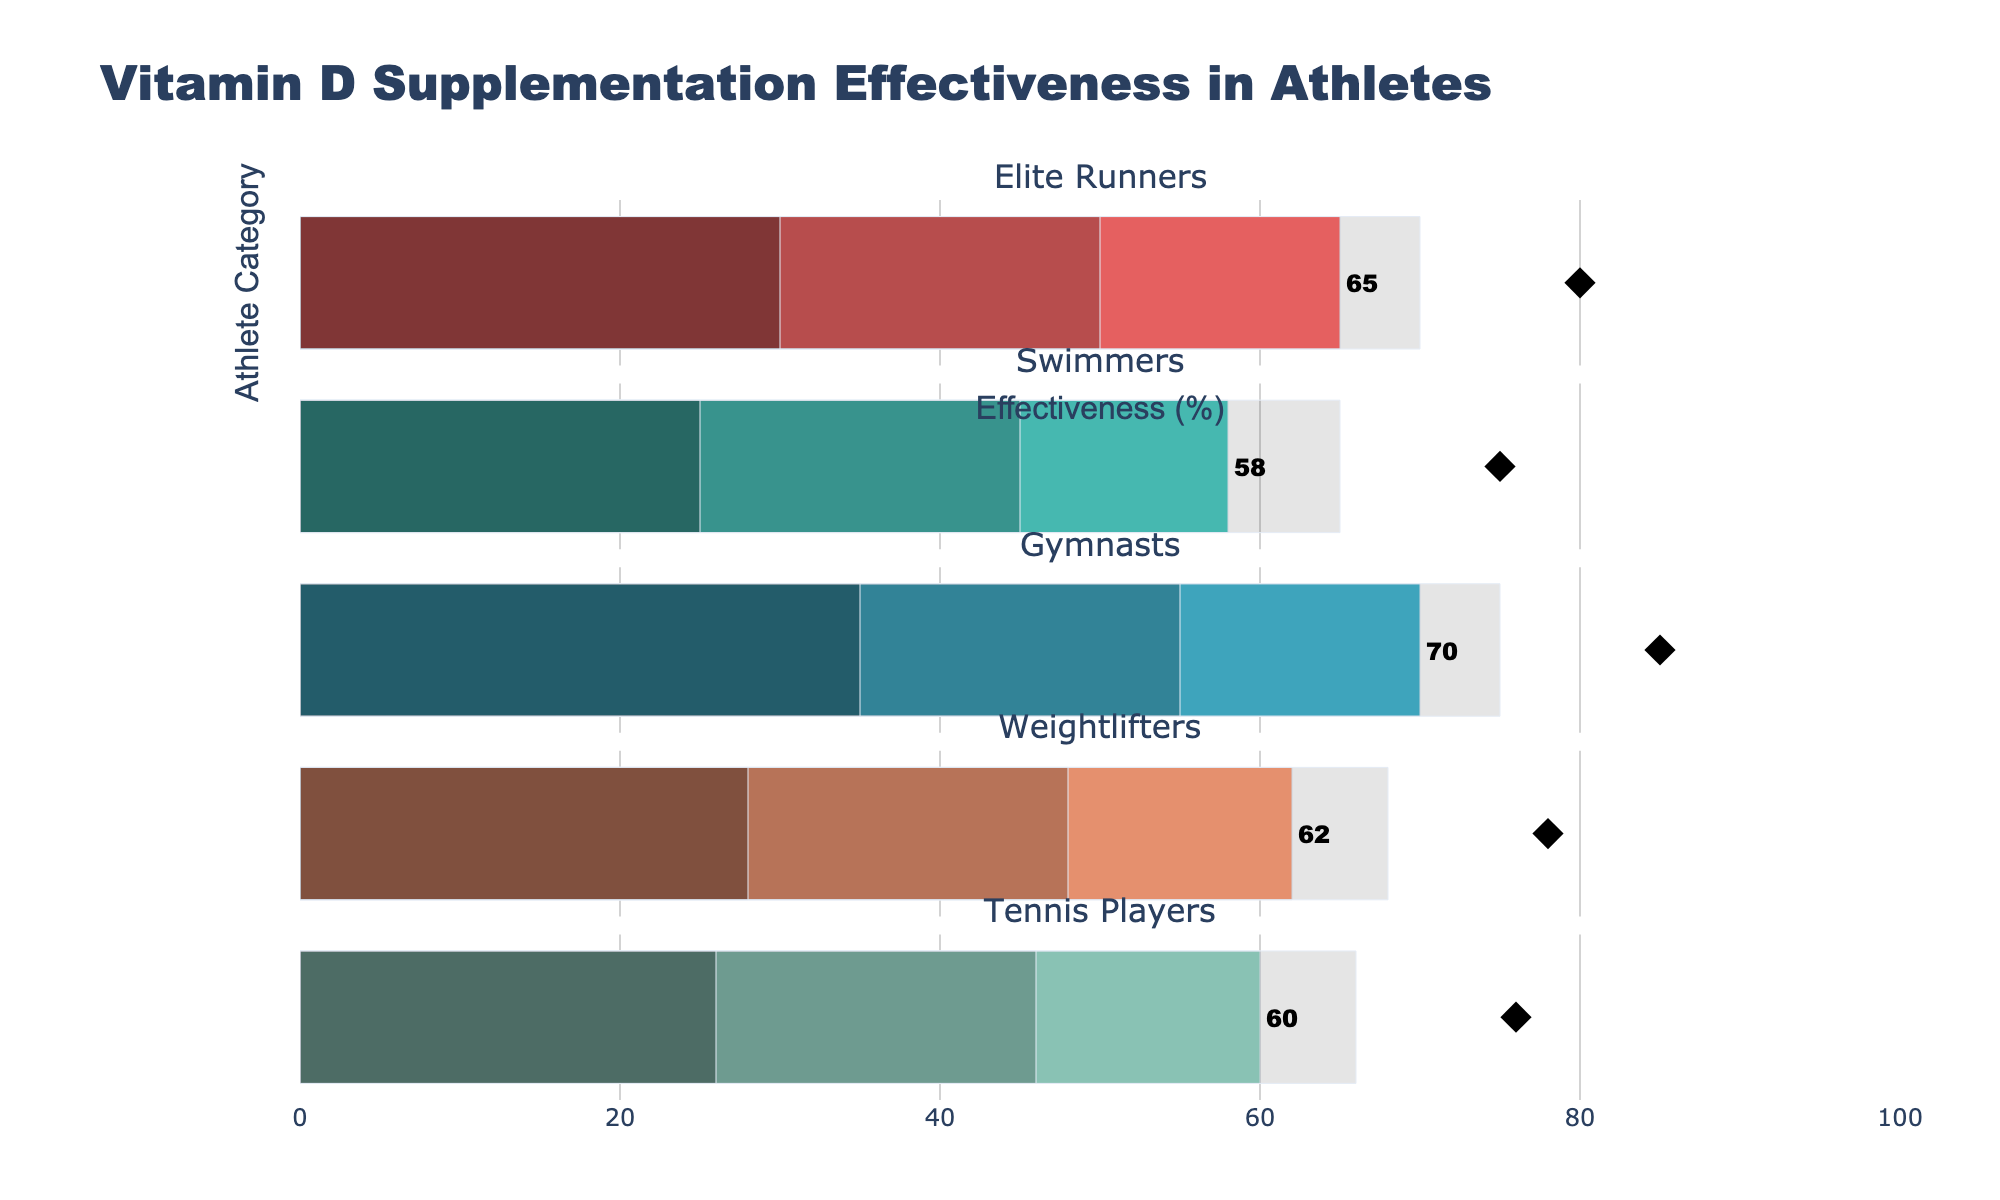What is the title of the figure? The title of the figure is located at the top and reads "Vitamin D Supplementation Effectiveness in Athletes".
Answer: Vitamin D Supplementation Effectiveness in Athletes What is the actual effectiveness percentage for Elite Runners? The actual effectiveness for each athlete category is represented by the bar with a specific color and the text label "Actual" beneath it. For Elite Runners, this bar indicates an effectiveness of 65%.
Answer: 65% Which athlete category has the highest target percentage for Vitamin D effectiveness? To determine which category has the highest target percentage, look for the diamond marker labeled "Target" and check its corresponding value. Gymnasts have a target percentage of 85%, the highest among all categories.
Answer: Gymnasts What is the difference between the actual and target effectiveness for Weightlifters? For Weightlifters, the actual effectiveness is 62%, and the target is 78%. The difference can be calculated as 78% - 62% = 16%.
Answer: 16% Which athlete categories have an actual effectiveness percentage greater than their respective Range2 value? By comparing each category's actual effectiveness percentage with their Range2 value: Elite Runners (65 > 50), Swimmers (58 > 45), Gymnasts (70 > 55), Weightlifters (62 > 48), and Tennis Players (60 > 46). All categories have actual effectiveness greater than their Range2.
Answer: All categories How many categories nearly meet or exceed their target effectiveness? (Within 10% range) To find how many categories are within 10% of meeting or exceeding their target, examine the difference between the actual and target values. Elite Runners (65 vs. 80, diff = 15%), Swimmers (58 vs. 75, diff = 17%), Gymnasts (70 vs. 85, diff = 15%), Weightlifters (62 vs. 78, diff = 16%), Tennis Players (60 vs. 76, diff = 16%). None of the categories meet this criterion.
Answer: 0 Identify the athlete category with the lowest actual effectiveness and provide its rate. By reviewing the "Actual" bars, Swimmers have the lowest effectiveness percentage at 58%.
Answer: Swimmers, 58% What is the average actual effectiveness percentage across all athlete categories? Add the actual effectiveness values and divide by the number of categories: (65 + 58 + 70 + 62 + 60) / 5 = 63.
Answer: 63% Which athlete category has the narrowest range of values between Range1 and Range3? Calculate the difference between Range1 and Range3 for each category: Elite Runners (70 - 30 = 40), Swimmers (65 - 25 = 40), Gymnasts (75 - 35 = 40), Weightlifters (68 - 28 = 40), Tennis Players (66 - 26 = 40). All categories have the same difference of 40.
Answer: All categories Is there a category where the actual effectiveness is below the Range1 value? Compare the actual effectiveness values to their corresponding Range1 values. None fall below their Range1 values.
Answer: No 